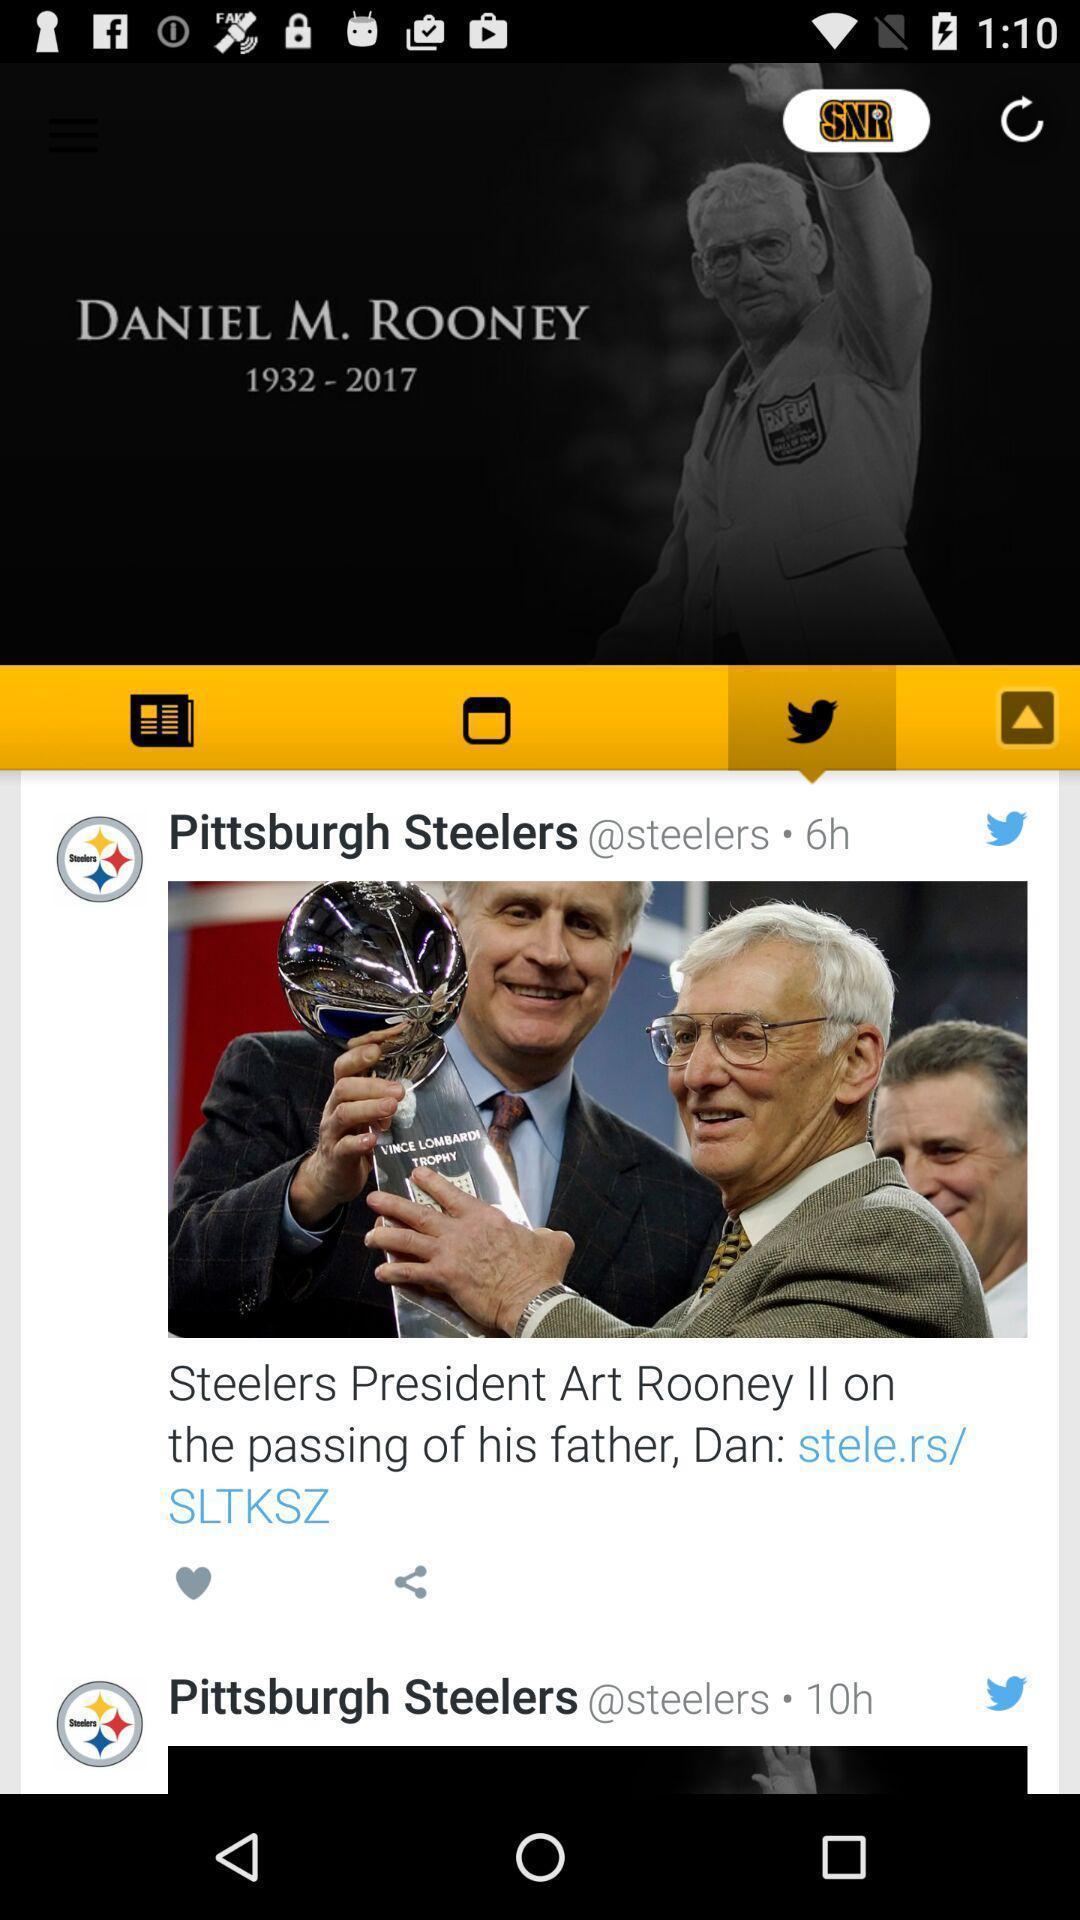Give me a narrative description of this picture. Social app with listed news feed and other options. 